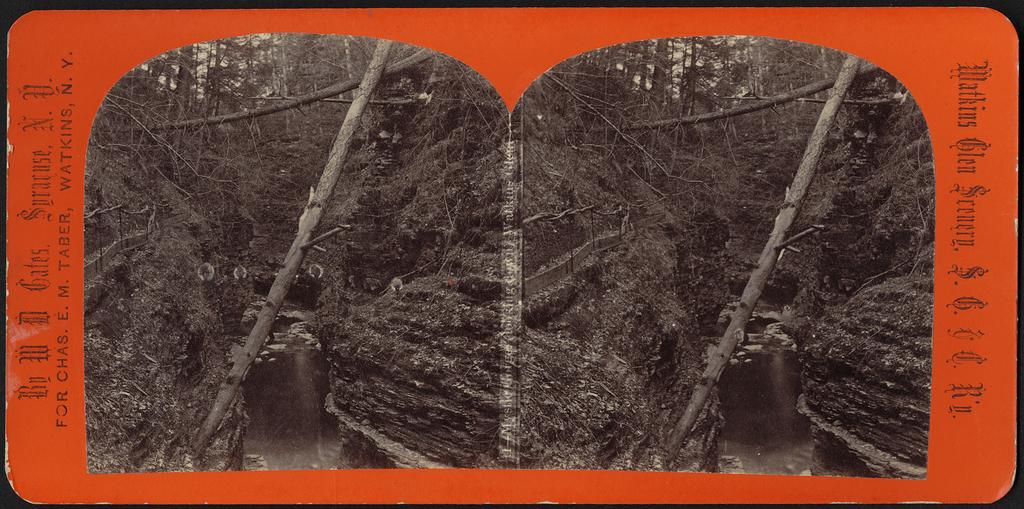What is present on the poster in the image? There is a poster in the image, with text on the sides and two identical images of trees. Can you describe the images on the poster? The images on the poster depict trees. What else can be seen in the image besides the poster? There is water visible in the image. How many geese are swimming in the water in the image? There are no geese present in the image; only the poster and water are visible. On which side of the poster can a snail be seen? There is no snail present in the image; only the poster and water are visible. 